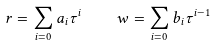<formula> <loc_0><loc_0><loc_500><loc_500>r = \sum _ { i = 0 } a _ { i } \tau ^ { i } \quad w = \sum _ { i = 0 } b _ { i } \tau ^ { i - 1 }</formula> 